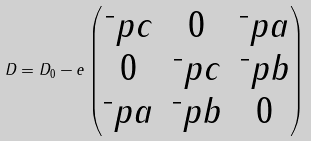<formula> <loc_0><loc_0><loc_500><loc_500>D = D _ { 0 } - e \begin{pmatrix} \bar { \ } p c & 0 & \bar { \ } p a \\ 0 & \bar { \ } p c & \bar { \ } p b \\ \bar { \ } p a & \bar { \ } p b & 0 \end{pmatrix}</formula> 